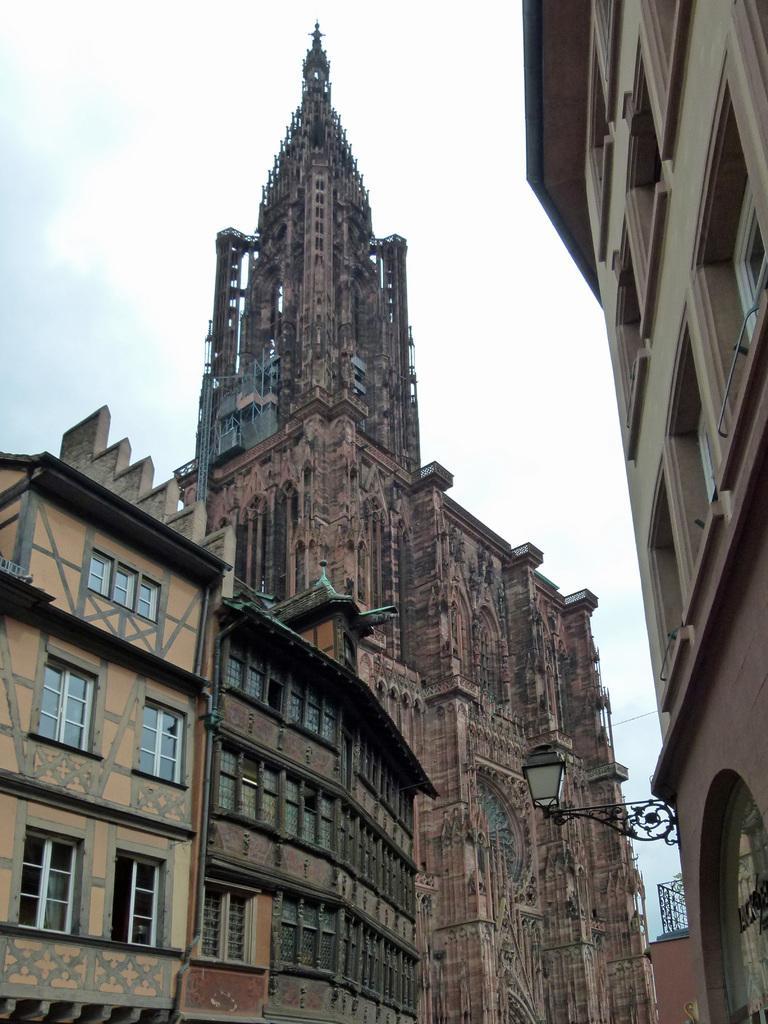In one or two sentences, can you explain what this image depicts? In this image, we can see buildings. There is a light on the building. In the background of the image, there is a sky. 